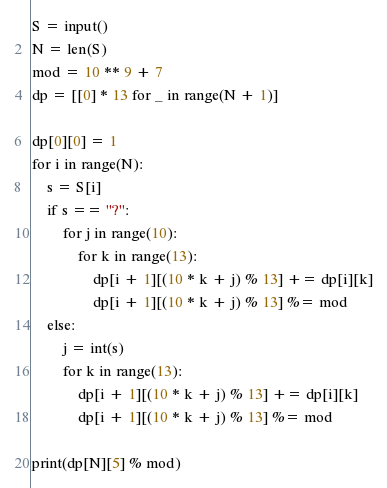<code> <loc_0><loc_0><loc_500><loc_500><_Python_>S = input()
N = len(S)
mod = 10 ** 9 + 7
dp = [[0] * 13 for _ in range(N + 1)]

dp[0][0] = 1
for i in range(N):
    s = S[i]
    if s == "?":
        for j in range(10):
            for k in range(13):
                dp[i + 1][(10 * k + j) % 13] += dp[i][k]
                dp[i + 1][(10 * k + j) % 13] %= mod
    else:
        j = int(s)
        for k in range(13):
            dp[i + 1][(10 * k + j) % 13] += dp[i][k]
            dp[i + 1][(10 * k + j) % 13] %= mod

print(dp[N][5] % mod)
</code> 